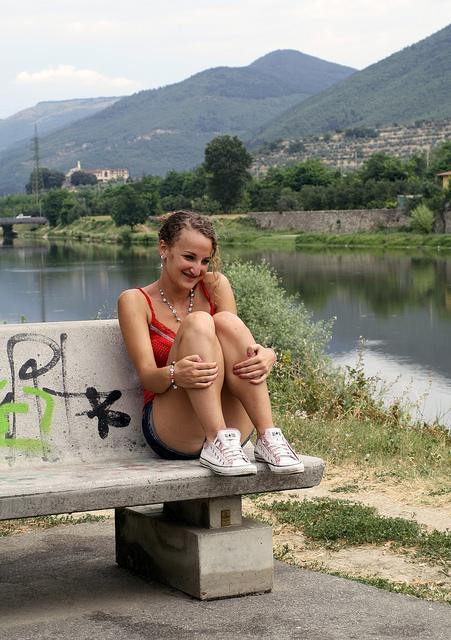How does this person feel about the photographer?

Choices:
A) likes alot
B) wary
C) hates
D) spiteful likes alot 